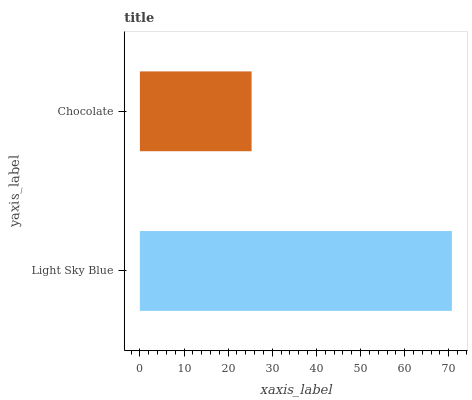Is Chocolate the minimum?
Answer yes or no. Yes. Is Light Sky Blue the maximum?
Answer yes or no. Yes. Is Chocolate the maximum?
Answer yes or no. No. Is Light Sky Blue greater than Chocolate?
Answer yes or no. Yes. Is Chocolate less than Light Sky Blue?
Answer yes or no. Yes. Is Chocolate greater than Light Sky Blue?
Answer yes or no. No. Is Light Sky Blue less than Chocolate?
Answer yes or no. No. Is Light Sky Blue the high median?
Answer yes or no. Yes. Is Chocolate the low median?
Answer yes or no. Yes. Is Chocolate the high median?
Answer yes or no. No. Is Light Sky Blue the low median?
Answer yes or no. No. 